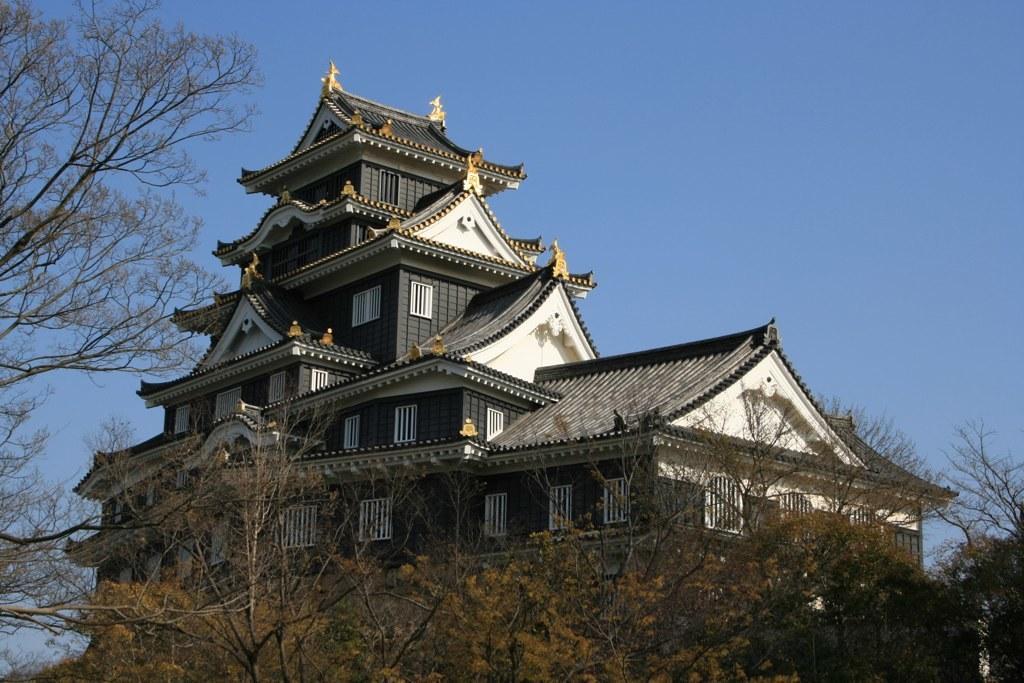In one or two sentences, can you explain what this image depicts? In this image we can see the house with the windows. We can also see the trees. In the background, we can see the sky. 